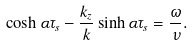Convert formula to latex. <formula><loc_0><loc_0><loc_500><loc_500>\cosh \alpha \tau _ { s } - \frac { k _ { z } } { k } \sinh \alpha \tau _ { s } = \frac { \omega } { \nu } .</formula> 